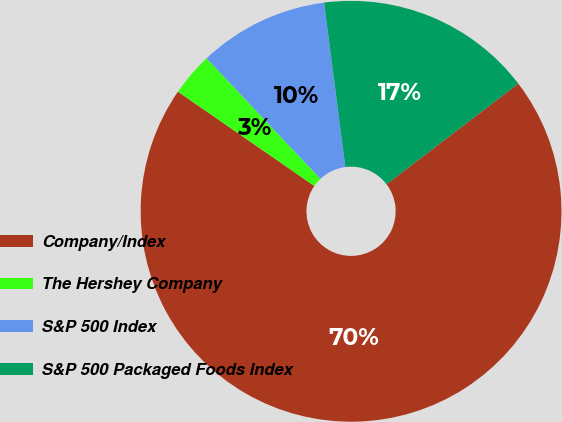<chart> <loc_0><loc_0><loc_500><loc_500><pie_chart><fcel>Company/Index<fcel>The Hershey Company<fcel>S&P 500 Index<fcel>S&P 500 Packaged Foods Index<nl><fcel>70.0%<fcel>3.33%<fcel>10.0%<fcel>16.67%<nl></chart> 